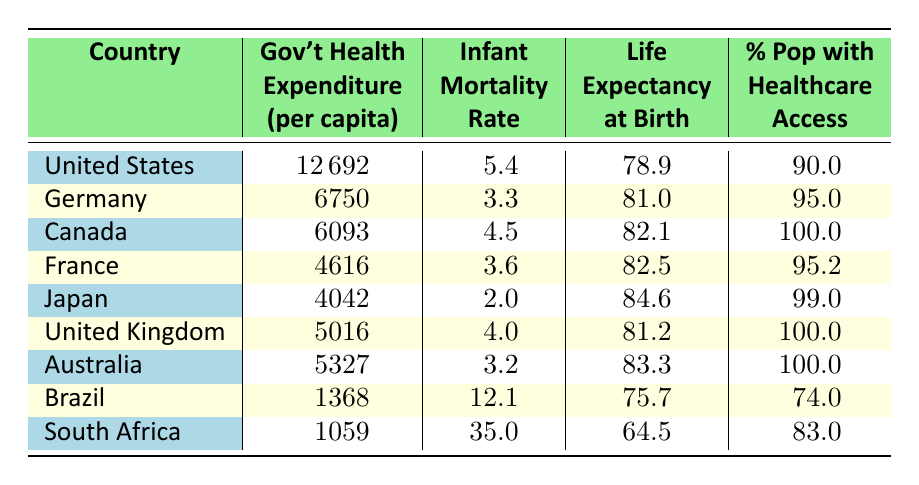What is the government health expenditure per capita for Japan? The table lists Japan's government health expenditure per capita directly, which is 4042.
Answer: 4042 Which country has the highest infant mortality rate? By examining the infant mortality rates in the table, South Africa has the highest rate at 35.0.
Answer: South Africa What is the average life expectancy at birth for the countries listed? Add the life expectancy values for all countries: (78.9 + 81.0 + 82.1 + 82.5 + 84.6 + 81.2 + 83.3 + 75.7 + 64.5) =  783.8, divide by the number of countries (9) to get an average of approximately 87.09.
Answer: 87.09 Is the percentage of the population with access to healthcare highest in Canada? Checking the table, Canada has 100.0% access, which is the highest among all listed countries.
Answer: Yes What is the difference in government health expenditure per capita between the United States and Brazil? The difference is calculated by subtracting Brazil's expenditure (1368) from the United States' expenditure (12692): 12692 - 1368 = 11324.
Answer: 11324 What percentage of the population in South Africa has access to healthcare? According to the table, South Africa has access to healthcare for 83.0% of its population.
Answer: 83.0 How many countries have a life expectancy at birth above 80? By reviewing the life expectancy values, there are 5 countries (Germany, Canada, France, Japan, Australia) with values above 80.
Answer: 5 If a country has a government health expenditure under 2000, is its infant mortality rate higher than the average of all countries? First, calculate the average infant mortality rate (5.4 + 3.3 + 4.5 + 3.6 + 2.0 + 4.0 + 3.2 + 12.1 + 35.0 = 73.1; 73.1/9 = 8.12). Brazil (12.1) and South Africa (35.0) both fall under 2000 and exceed the average.
Answer: Yes What country has both the lowest government health expenditure and the highest infant mortality rate? South Africa has the lowest government health expenditure (1059) and the highest infant mortality rate (35.0) among the listed countries.
Answer: South Africa 